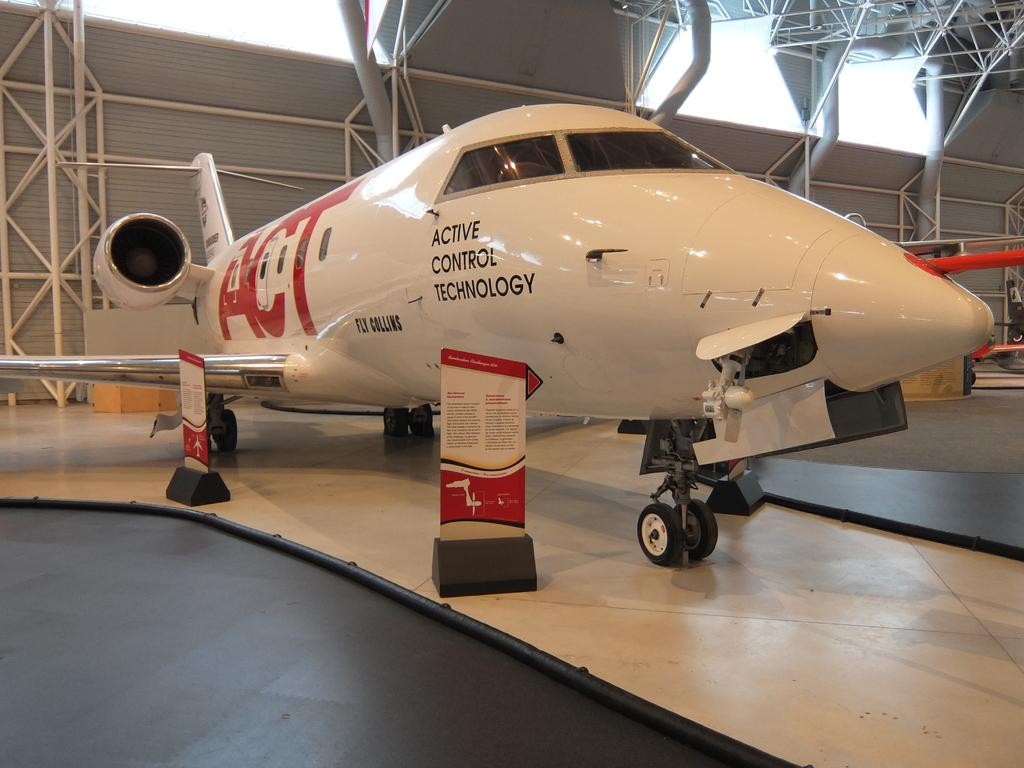<image>
Render a clear and concise summary of the photo. A white plane has ACT in red on the side of it. 